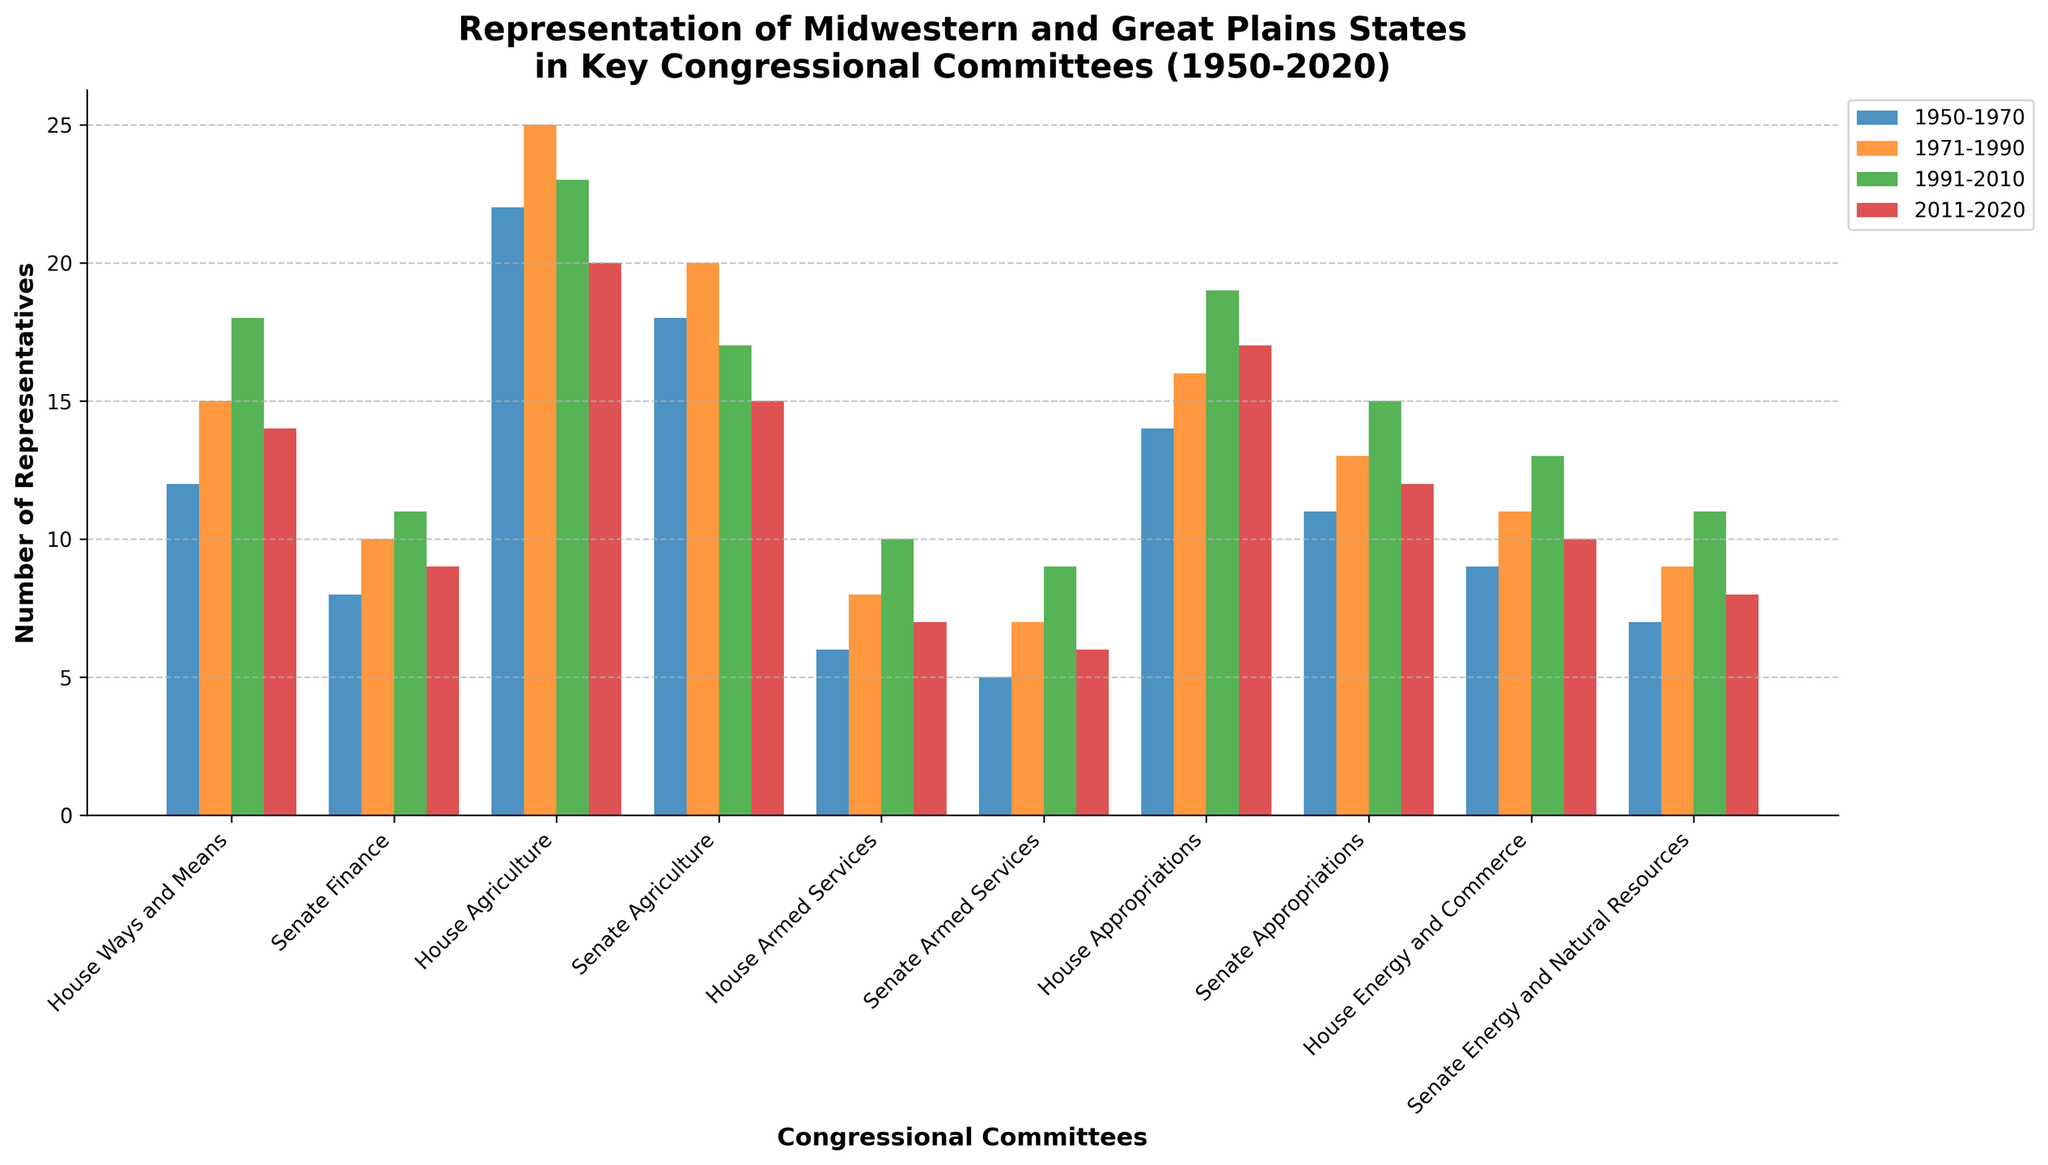What committee shows the highest representation for the period 2011-2020? Look at the bars for the period 2011-2020 in the figure. Find the tallest bar, which represents the highest number of representatives. This is for the House Agriculture committee.
Answer: House Agriculture Which committee experienced the largest increase in representation from 1950-1970 to 1991-2010? Calculate the increase for each committee by subtracting the value for the period 1950-1970 from the value for the period 1991-2010. The House Appropriations committee increased from 14 to 19, which is an increase of 5. This is the largest increase.
Answer: House Appropriations Compare the representation in the House Agriculture committee from the period 1950-1970 to 2011-2020. Subtract the value for 2011-2020 (20) from the value for 1950-1970 (22). This gives a difference of 2. Therefore, representation has slightly decreased.
Answer: 2 fewer representatives Which period has the least representation across all committees combined? Sum the values for each period across all committees. For 1950-1970, the sum is 112, for 1971-1990, it is 134, for 1991-2010, it is 146, and for 2011-2020, it is 128. The period 1950-1970 has the least with a sum of 112.
Answer: 1950-1970 Compare the trend in representation for the Senate Finance and Senate Agriculture committees over the periods. Observe the height of the bars over the periods for both Senate Finance and Senate Agriculture committees. The trend for both started increasing from 1950-1990 but then slightly decreased from 1991-2020, indicating a similar pattern.
Answer: Similar decreasing trend Which committee had the greatest fluctuation in representation over the periods shown? Calculate the difference between the highest and lowest representation for each committee. The House Agriculture committee fluctuated from a high of 25 to a low of 20, with a difference of 5, making it the committee with the greatest fluctuation.
Answer: House Agriculture Which committee consistently had the least representation across all periods? Identify the committee with the lowest bars in multiple periods. The Senate Armed Services committee had consistent low representation with values of 5, 7, 9, and 6.
Answer: Senate Armed Services How does the representation in the House Appropriations committee in 1991-2010 compare with the representation in the Senate Appropriations committee in the same period? Compare the heights of the bars for House Appropriations and Senate Appropriations committees for 1991-2010. House Appropriations had 19 representatives and Senate Appropriations had 15. The House Appropriations committee had more representatives.
Answer: House Appropriations had 4 more representatives What is the average representation in the Senate Agriculture committee over all periods? Add the numbers for the Senate Agriculture committee for all periods: 18, 20, 17, and 15. The total is 70. Divide by the number of periods (4) to find the average: 70/4 = 17.5.
Answer: 17.5 